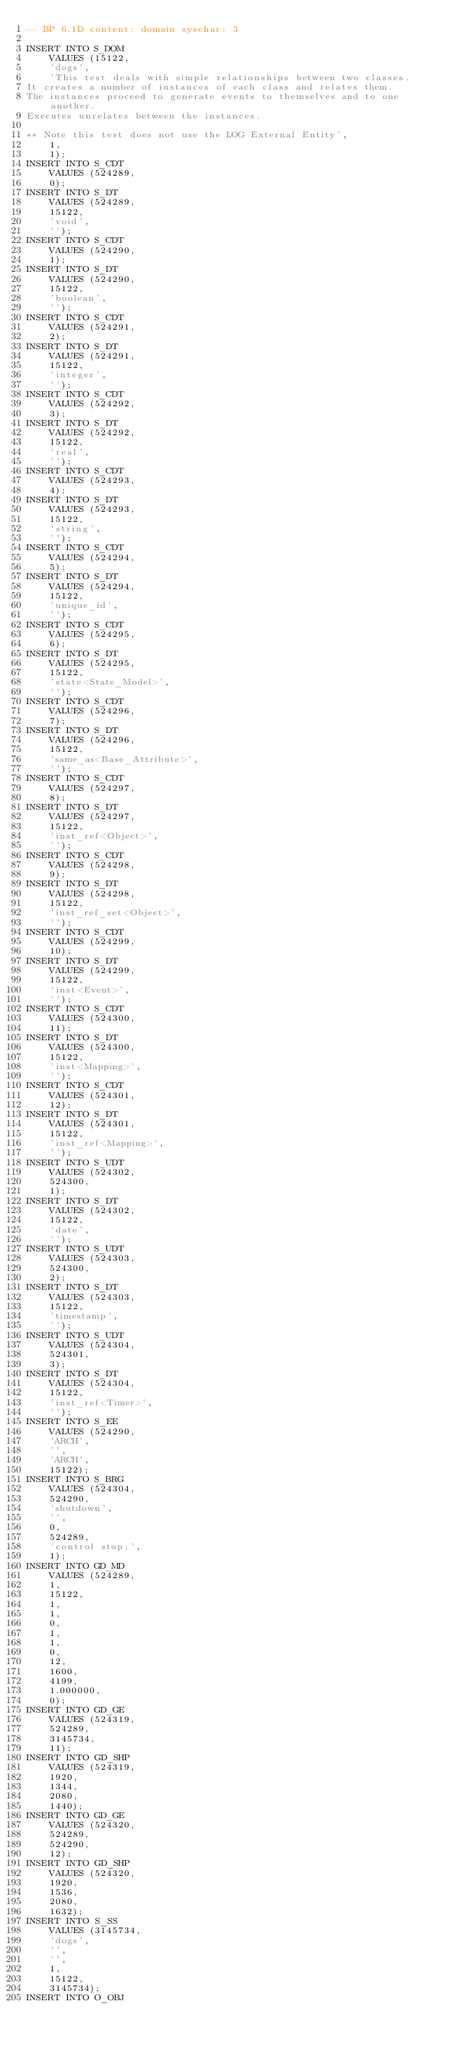Convert code to text. <code><loc_0><loc_0><loc_500><loc_500><_SQL_>-- BP 6.1D content: domain syschar: 3

INSERT INTO S_DOM
	VALUES (15122,
	'dogs',
	'This test deals with simple relationships between two classes.
It creates a number of instances of each class and relates them.
The instances proceed to generate events to themselves and to one another.
Executes unrelates between the instances.

** Note this test does not use the LOG External Entity',
	1,
	1);
INSERT INTO S_CDT
	VALUES (524289,
	0);
INSERT INTO S_DT
	VALUES (524289,
	15122,
	'void',
	'');
INSERT INTO S_CDT
	VALUES (524290,
	1);
INSERT INTO S_DT
	VALUES (524290,
	15122,
	'boolean',
	'');
INSERT INTO S_CDT
	VALUES (524291,
	2);
INSERT INTO S_DT
	VALUES (524291,
	15122,
	'integer',
	'');
INSERT INTO S_CDT
	VALUES (524292,
	3);
INSERT INTO S_DT
	VALUES (524292,
	15122,
	'real',
	'');
INSERT INTO S_CDT
	VALUES (524293,
	4);
INSERT INTO S_DT
	VALUES (524293,
	15122,
	'string',
	'');
INSERT INTO S_CDT
	VALUES (524294,
	5);
INSERT INTO S_DT
	VALUES (524294,
	15122,
	'unique_id',
	'');
INSERT INTO S_CDT
	VALUES (524295,
	6);
INSERT INTO S_DT
	VALUES (524295,
	15122,
	'state<State_Model>',
	'');
INSERT INTO S_CDT
	VALUES (524296,
	7);
INSERT INTO S_DT
	VALUES (524296,
	15122,
	'same_as<Base_Attribute>',
	'');
INSERT INTO S_CDT
	VALUES (524297,
	8);
INSERT INTO S_DT
	VALUES (524297,
	15122,
	'inst_ref<Object>',
	'');
INSERT INTO S_CDT
	VALUES (524298,
	9);
INSERT INTO S_DT
	VALUES (524298,
	15122,
	'inst_ref_set<Object>',
	'');
INSERT INTO S_CDT
	VALUES (524299,
	10);
INSERT INTO S_DT
	VALUES (524299,
	15122,
	'inst<Event>',
	'');
INSERT INTO S_CDT
	VALUES (524300,
	11);
INSERT INTO S_DT
	VALUES (524300,
	15122,
	'inst<Mapping>',
	'');
INSERT INTO S_CDT
	VALUES (524301,
	12);
INSERT INTO S_DT
	VALUES (524301,
	15122,
	'inst_ref<Mapping>',
	'');
INSERT INTO S_UDT
	VALUES (524302,
	524300,
	1);
INSERT INTO S_DT
	VALUES (524302,
	15122,
	'date',
	'');
INSERT INTO S_UDT
	VALUES (524303,
	524300,
	2);
INSERT INTO S_DT
	VALUES (524303,
	15122,
	'timestamp',
	'');
INSERT INTO S_UDT
	VALUES (524304,
	524301,
	3);
INSERT INTO S_DT
	VALUES (524304,
	15122,
	'inst_ref<Timer>',
	'');
INSERT INTO S_EE
	VALUES (524290,
	'ARCH',
	'',
	'ARCH',
	15122);
INSERT INTO S_BRG
	VALUES (524304,
	524290,
	'shutdown',
	'',
	0,
	524289,
	'control stop;',
	1);
INSERT INTO GD_MD
	VALUES (524289,
	1,
	15122,
	1,
	1,
	0,
	1,
	1,
	0,
	12,
	1600,
	4199,
	1.000000,
	0);
INSERT INTO GD_GE
	VALUES (524319,
	524289,
	3145734,
	11);
INSERT INTO GD_SHP
	VALUES (524319,
	1920,
	1344,
	2080,
	1440);
INSERT INTO GD_GE
	VALUES (524320,
	524289,
	524290,
	12);
INSERT INTO GD_SHP
	VALUES (524320,
	1920,
	1536,
	2080,
	1632);
INSERT INTO S_SS
	VALUES (3145734,
	'dogs',
	'',
	'',
	1,
	15122,
	3145734);
INSERT INTO O_OBJ</code> 